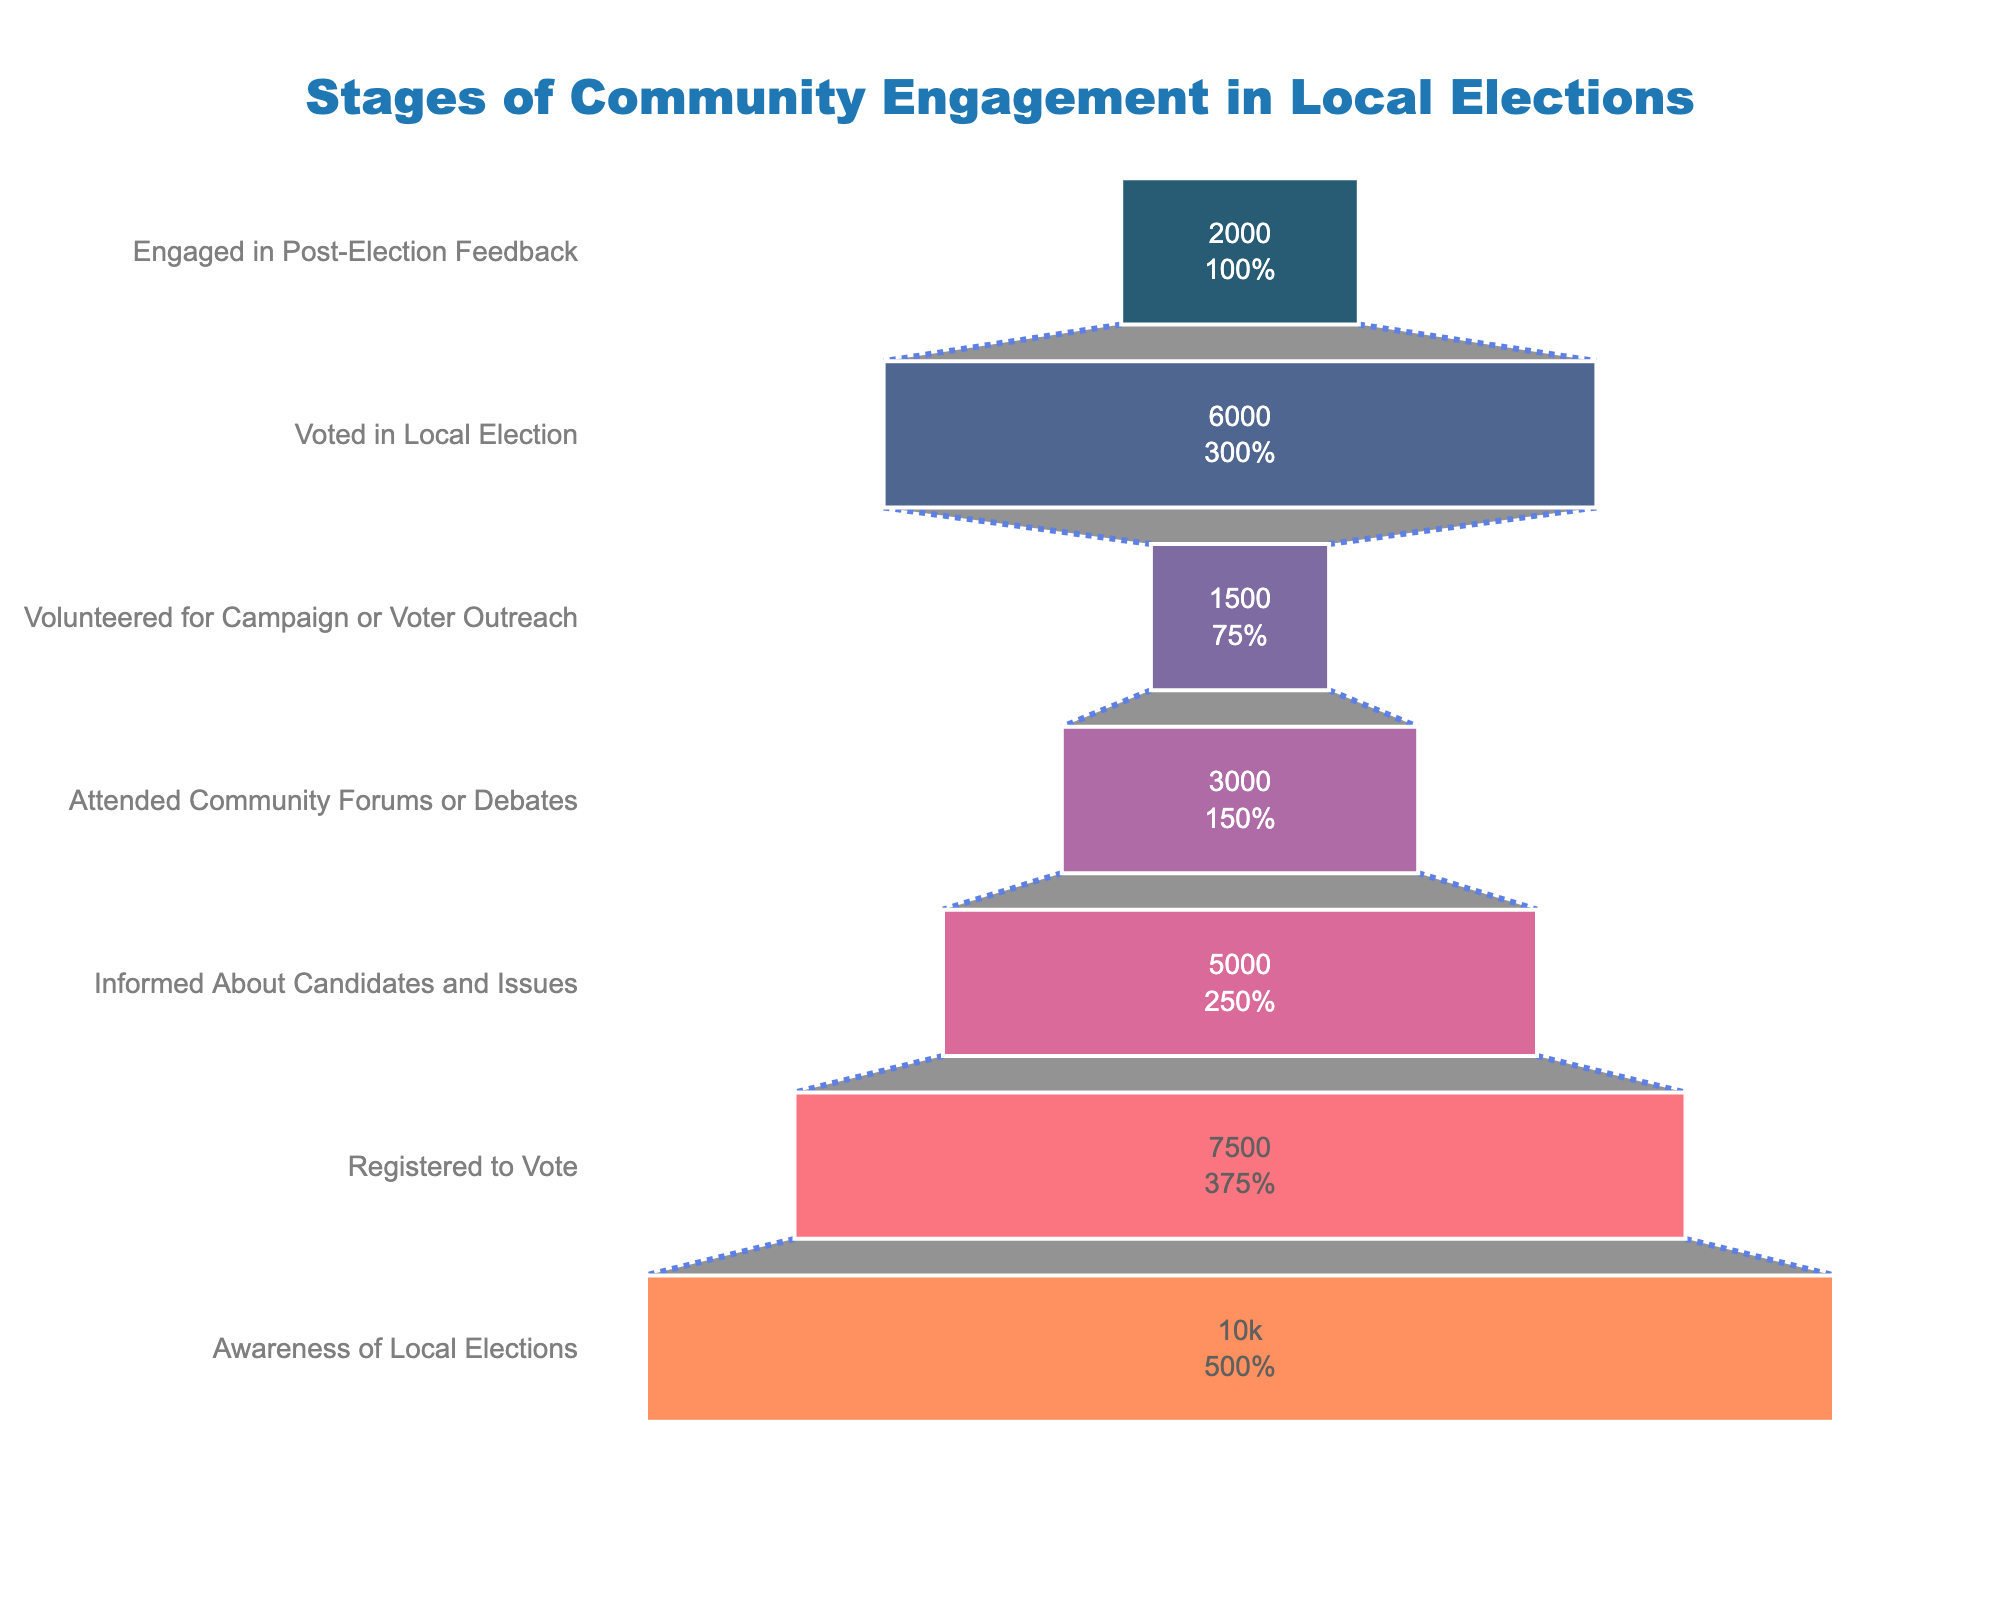What's the title of the chart? The title is located at the top center of the chart. It says "Stages of Community Engagement in Local Elections".
Answer: Stages of Community Engagement in Local Elections What is the number of participants registered to vote? The number of participants can be read directly from the funnel segment labeled "Registered to Vote".
Answer: 7500 How many more people are aware of local elections than those who are informed about candidates and issues? The number of participants aware of local elections is 10000, and the number informed about candidates and issues is 5000. Subtract the latter from the former: 10000 - 5000.
Answer: 5000 Which stage has the smallest number of participants? The smallest segment in the funnel indicates the stage with the least participants, which is "Volunteered for Campaign or Voter Outreach".
Answer: Volunteered for Campaign or Voter Outreach What's the combined number of participants that attended community forums or debates and those who engaged in post-election feedback? Add the number of participants who attended community forums or debates (3000) and those who engaged in post-election feedback (2000). 3000 + 2000.
Answer: 5000 Among the stages listed, which has more participants: those who volunteered for campaign or voter outreach or those who engaged in post-election feedback? Compare the two segments: "Volunteered for Campaign or Voter Outreach" has 1500 participants, whereas "Engaged in Post-Election Feedback" has 2000 participants. 2000 is greater than 1500.
Answer: Engaged in Post-Election Feedback How many stages show a decrease in the number of participants compared to the previous stage? Count the stages where the number of participants is less than the number in the previous stage. There are five stages (Registered to Vote, Informed About Candidates and Issues, Attended Community Forums or Debates, Volunteered for Campaign or Voter Outreach, Engaged in Post-Election Feedback) that show a decrease compared to their preceding stage.
Answer: 5 What percentage reduction is seen when comparing participants registered to vote to those who attended community forums or debates? First, find the difference: 7500 (Registered to Vote) - 3000 (Attended Community Forums or Debates) = 4500. Then, calculate the percentage reduction: 4500 / 7500 * 100 = 60%.
Answer: 60% 